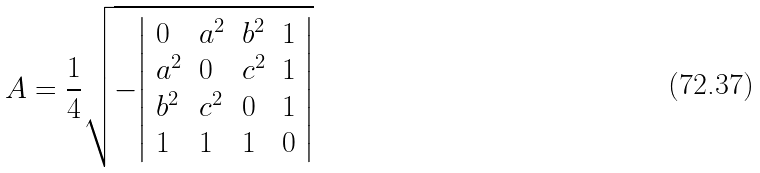Convert formula to latex. <formula><loc_0><loc_0><loc_500><loc_500>A = { \frac { 1 } { 4 } } { \sqrt { - { \left | \begin{array} { l l l l } { 0 } & { a ^ { 2 } } & { b ^ { 2 } } & { 1 } \\ { a ^ { 2 } } & { 0 } & { c ^ { 2 } } & { 1 } \\ { b ^ { 2 } } & { c ^ { 2 } } & { 0 } & { 1 } \\ { 1 } & { 1 } & { 1 } & { 0 } \end{array} \right | } } }</formula> 